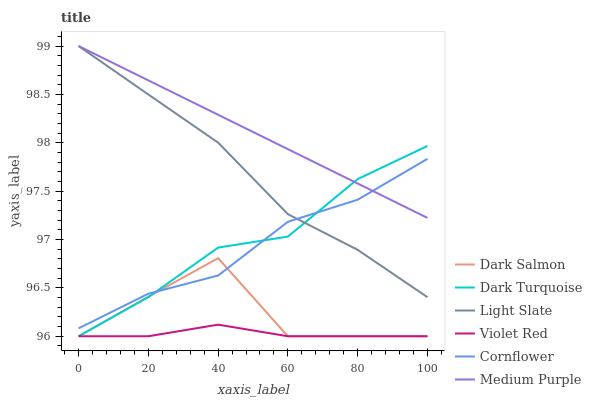Does Violet Red have the minimum area under the curve?
Answer yes or no. Yes. Does Medium Purple have the maximum area under the curve?
Answer yes or no. Yes. Does Light Slate have the minimum area under the curve?
Answer yes or no. No. Does Light Slate have the maximum area under the curve?
Answer yes or no. No. Is Medium Purple the smoothest?
Answer yes or no. Yes. Is Dark Salmon the roughest?
Answer yes or no. Yes. Is Violet Red the smoothest?
Answer yes or no. No. Is Violet Red the roughest?
Answer yes or no. No. Does Violet Red have the lowest value?
Answer yes or no. Yes. Does Light Slate have the lowest value?
Answer yes or no. No. Does Medium Purple have the highest value?
Answer yes or no. Yes. Does Violet Red have the highest value?
Answer yes or no. No. Is Violet Red less than Light Slate?
Answer yes or no. Yes. Is Light Slate greater than Dark Salmon?
Answer yes or no. Yes. Does Violet Red intersect Dark Salmon?
Answer yes or no. Yes. Is Violet Red less than Dark Salmon?
Answer yes or no. No. Is Violet Red greater than Dark Salmon?
Answer yes or no. No. Does Violet Red intersect Light Slate?
Answer yes or no. No. 